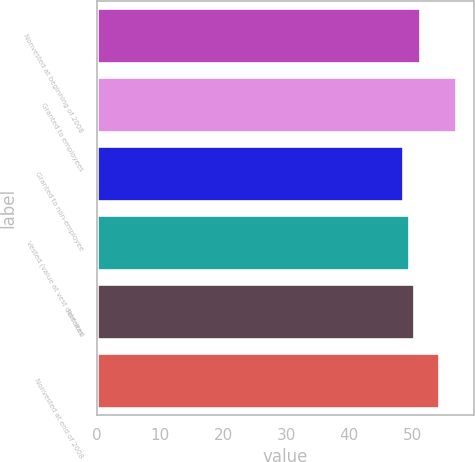Convert chart. <chart><loc_0><loc_0><loc_500><loc_500><bar_chart><fcel>Nonvested at beginning of 2008<fcel>Granted to employees<fcel>Granted to non-employee<fcel>Vested (value at vest date was<fcel>Forfeited<fcel>Nonvested at end of 2008<nl><fcel>51.16<fcel>56.91<fcel>48.54<fcel>49.48<fcel>50.32<fcel>54.28<nl></chart> 